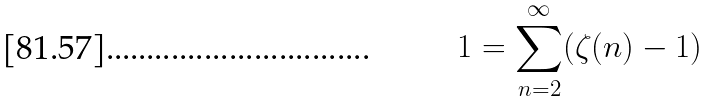<formula> <loc_0><loc_0><loc_500><loc_500>1 = \sum _ { n = 2 } ^ { \infty } ( \zeta ( n ) - 1 )</formula> 